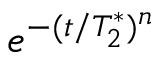Convert formula to latex. <formula><loc_0><loc_0><loc_500><loc_500>e ^ { - ( t / T _ { 2 } ^ { * } ) ^ { n } }</formula> 